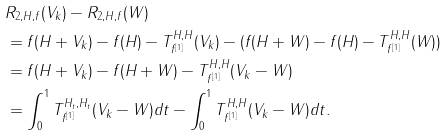<formula> <loc_0><loc_0><loc_500><loc_500>& R _ { 2 , H , f } ( V _ { k } ) - R _ { 2 , H , f } ( W ) \\ & = f ( H + V _ { k } ) - f ( H ) - T ^ { H , H } _ { f ^ { [ 1 ] } } ( V _ { k } ) - ( f ( H + W ) - f ( H ) - T ^ { H , H } _ { f ^ { [ 1 ] } } ( W ) ) \\ & = f ( H + V _ { k } ) - f ( H + W ) - T ^ { H , H } _ { f ^ { [ 1 ] } } ( V _ { k } - W ) \\ & = \int _ { 0 } ^ { 1 } T ^ { H _ { t } , H _ { t } } _ { f ^ { [ 1 ] } } ( V _ { k } - W ) d t - \int _ { 0 } ^ { 1 } T ^ { H , H } _ { f ^ { [ 1 ] } } ( V _ { k } - W ) d t .</formula> 